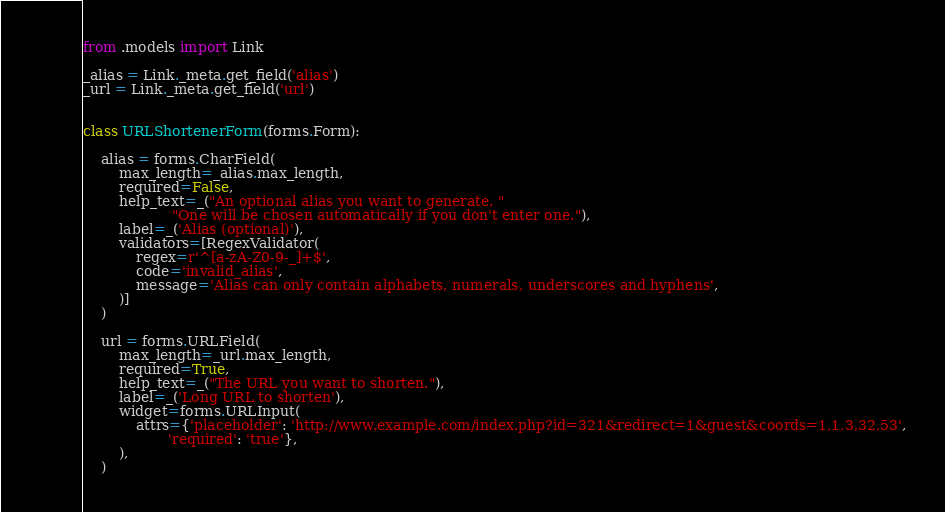Convert code to text. <code><loc_0><loc_0><loc_500><loc_500><_Python_>from .models import Link

_alias = Link._meta.get_field('alias')
_url = Link._meta.get_field('url')


class URLShortenerForm(forms.Form):

    alias = forms.CharField(
        max_length=_alias.max_length,
        required=False,
        help_text=_("An optional alias you want to generate. "
                    "One will be chosen automatically if you don't enter one."),
        label=_('Alias (optional)'),
        validators=[RegexValidator(
            regex=r'^[a-zA-Z0-9-_]+$',
            code='invalid_alias',
            message='Alias can only contain alphabets, numerals, underscores and hyphens',
        )]
    )

    url = forms.URLField(
        max_length=_url.max_length,
        required=True,
        help_text=_("The URL you want to shorten."),
        label=_('Long URL to shorten'),
        widget=forms.URLInput(
            attrs={'placeholder': 'http://www.example.com/index.php?id=321&redirect=1&guest&coords=1,1,3,32,53',
                   'required': 'true'},
        ),
    )
</code> 